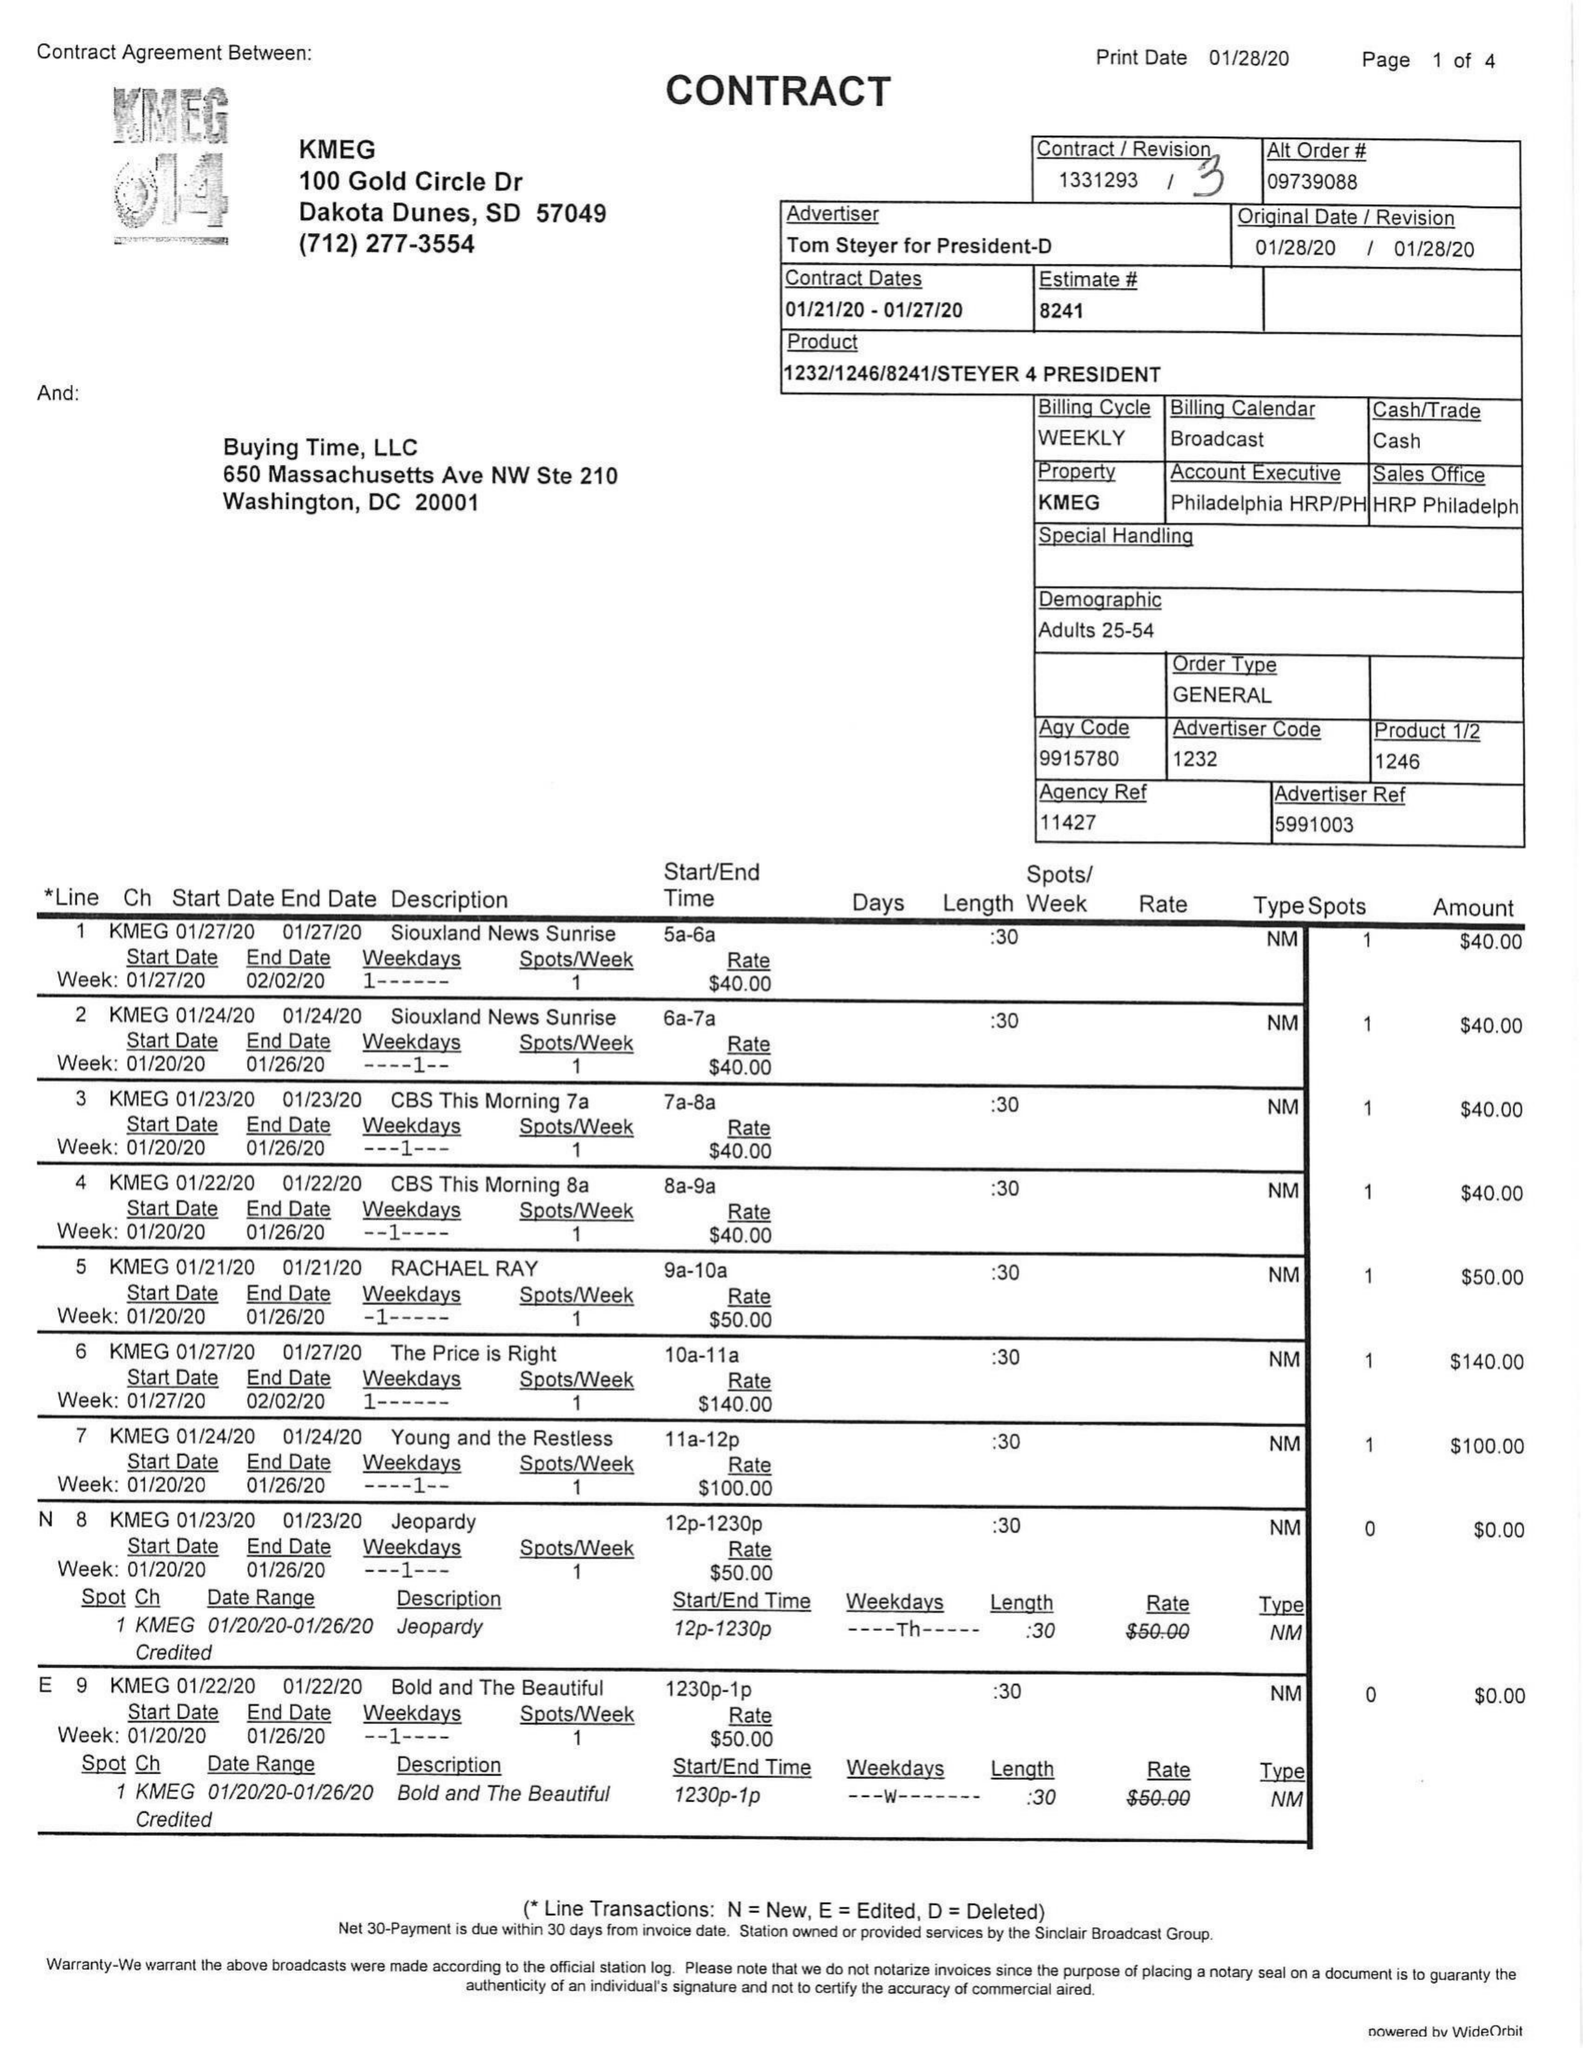What is the value for the gross_amount?
Answer the question using a single word or phrase. 6975.00 